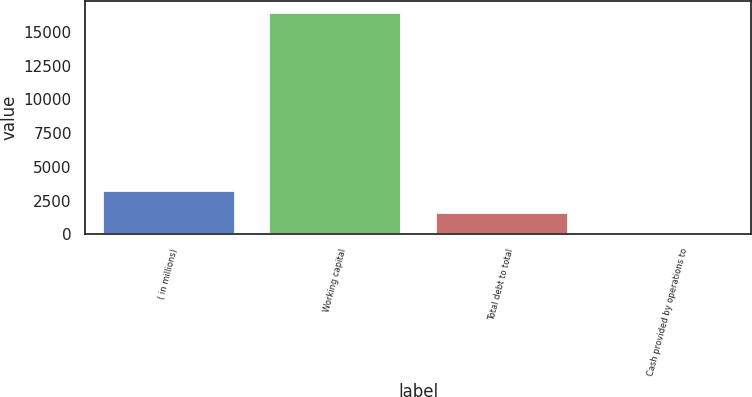Convert chart. <chart><loc_0><loc_0><loc_500><loc_500><bar_chart><fcel>( in millions)<fcel>Working capital<fcel>Total debt to total<fcel>Cash provided by operations to<nl><fcel>3302.21<fcel>16509<fcel>1651.36<fcel>0.51<nl></chart> 